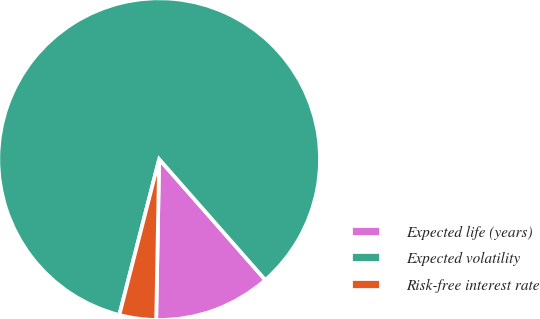<chart> <loc_0><loc_0><loc_500><loc_500><pie_chart><fcel>Expected life (years)<fcel>Expected volatility<fcel>Risk-free interest rate<nl><fcel>11.77%<fcel>84.55%<fcel>3.69%<nl></chart> 